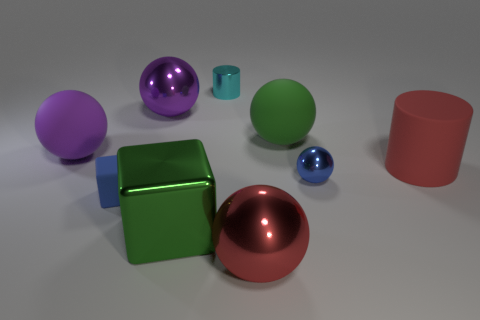Subtract 1 spheres. How many spheres are left? 4 Subtract all green matte balls. How many balls are left? 4 Subtract all red balls. How many balls are left? 4 Subtract all red spheres. Subtract all gray cylinders. How many spheres are left? 4 Subtract all spheres. How many objects are left? 4 Subtract 1 cyan cylinders. How many objects are left? 8 Subtract all small yellow metallic objects. Subtract all big green balls. How many objects are left? 8 Add 4 small blue metallic objects. How many small blue metallic objects are left? 5 Add 8 shiny blocks. How many shiny blocks exist? 9 